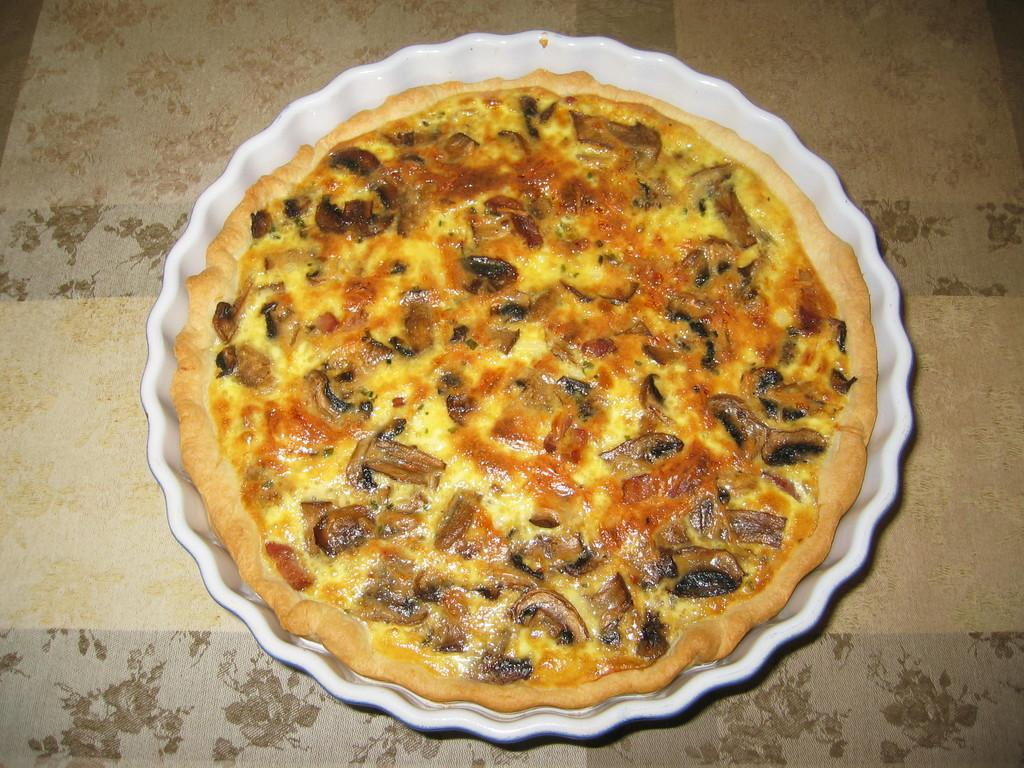What is the main food item visible in the image? There is a pizza on a plate in the image. What type of finger can be seen holding the pizza in the image? There are no fingers visible in the image, as it only features a pizza on a plate. What material is the tin used for serving the pizza made of in the image? There is no tin present in the image; it is a pizza on a plate. 